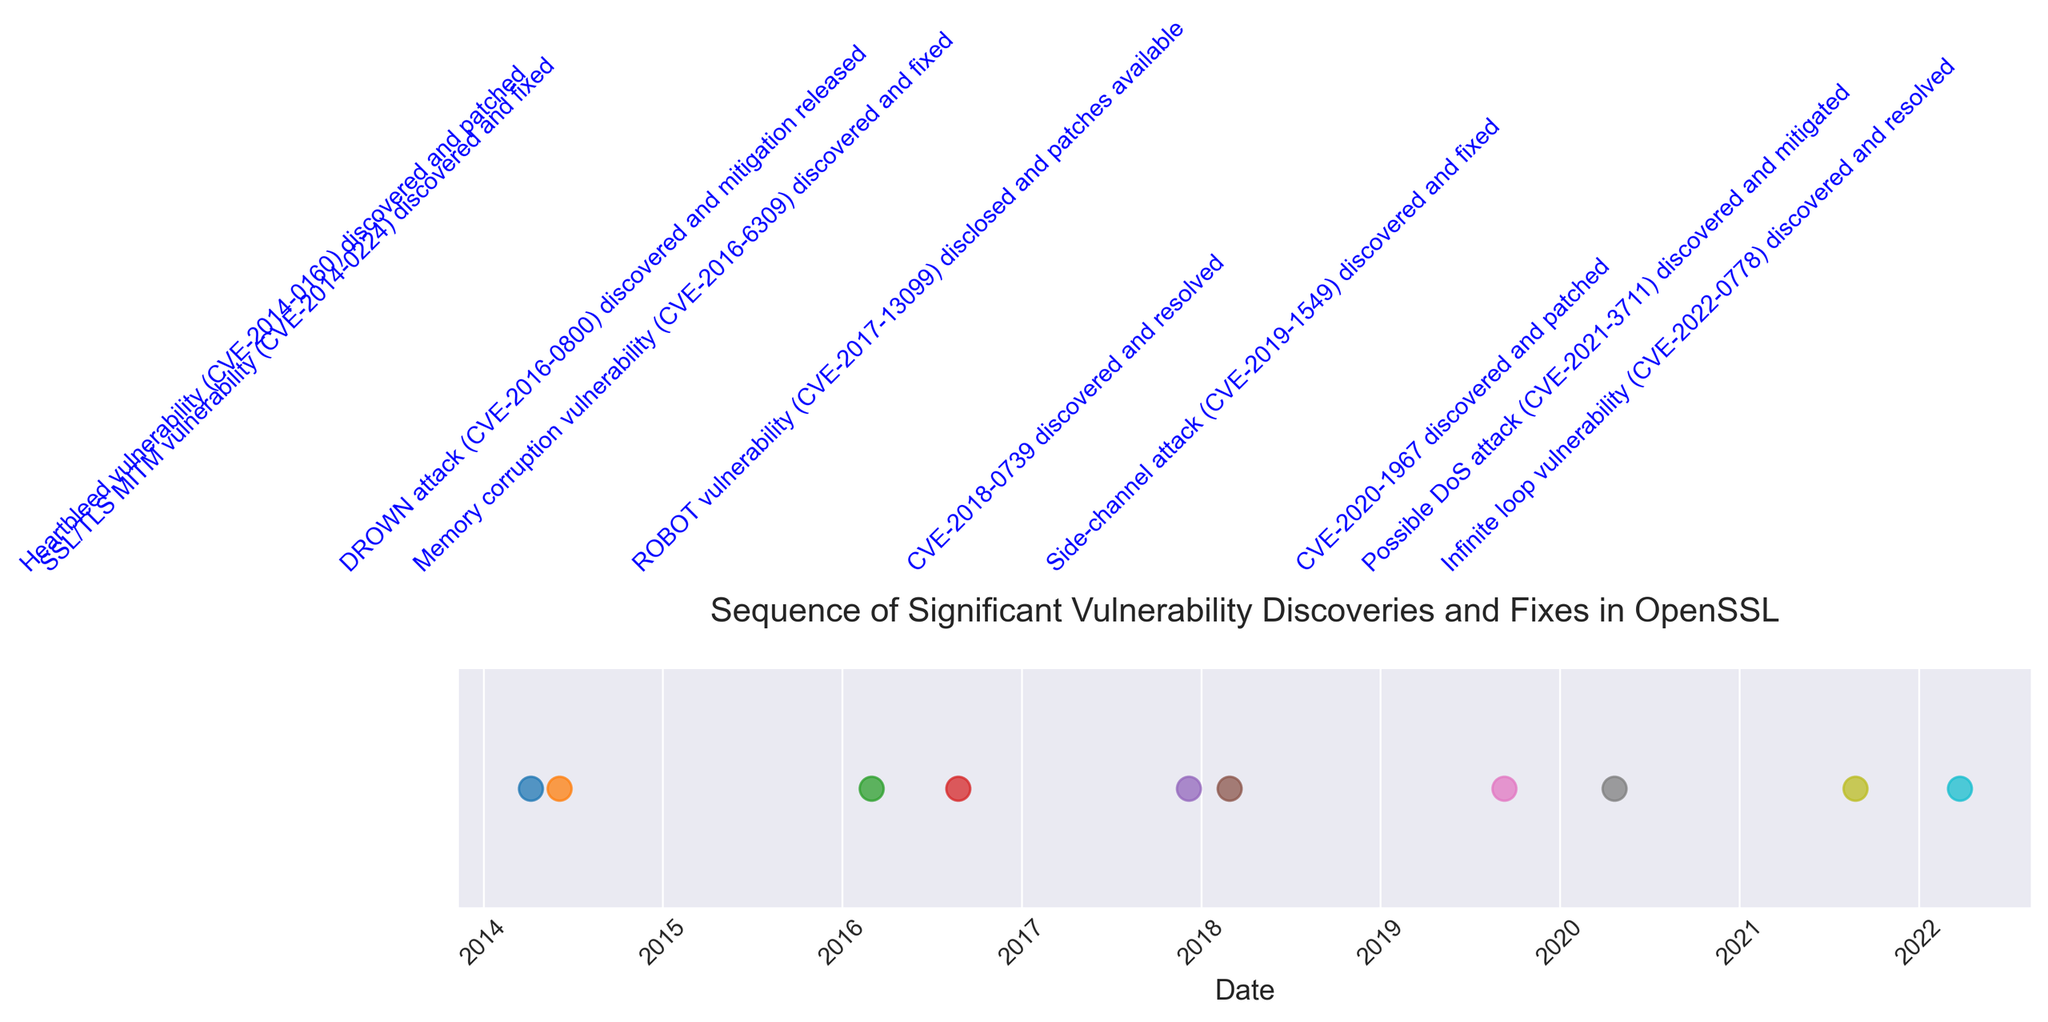When was the Heartbleed vulnerability discovered and patched? The event text directly states the Heartbleed vulnerability (CVE-2014-0160) was discovered and patched on 2014-04-07.
Answer: 2014-04-07 How many vulnerabilities were discovered between 2014 and 2016? Based on the dates provided in the figure, five vulnerabilities were discovered and fixed between 2014-04-07 and 2016-08-24.
Answer: 5 Which year had the highest number of significant vulnerabilities discovered and fixed? By counting the number of events per year, 2016 had the highest number of events with two significant vulnerabilities discovered and fixed.
Answer: 2016 Which event occurred last in the timeline? The last event on the timeline is the Infinite loop vulnerability (CVE-2022-0778) discovered and resolved, which occurred on 2022-03-25.
Answer: Infinite loop vulnerability (CVE-2022-0778) Comparing the Heartbleed vulnerability and the Infinite loop vulnerability, which one happened first? The Heartbleed vulnerability happened on 2014-04-07, whereas the Infinite loop vulnerability happened on 2022-03-25. Therefore, the Heartbleed vulnerability occurred first.
Answer: Heartbleed vulnerability What is the median date for the vulnerability fixes listed in the figure? To find the median date, first arrange all dates in chronological order and find the middle value. The middle date is 2017-12-07 (ROBOT vulnerability).
Answer: 2017-12-07 Were there more vulnerabilities discovered in the first or second half of the displayed timeline (2014-2022)? Dividing the timeline into two halves (2014-2018 and 2019-2022), there are 6 vulnerabilities in the first half and 4 in the second half. Thus, more vulnerabilities were discovered in the first half.
Answer: First half (2014-2018) Which event is associated with the earliest date in the figure? The Heartbleed vulnerability (CVE-2014-0160) is associated with the earliest date, 2014-04-07, in the timeline.
Answer: Heartbleed vulnerability (CVE-2014-0160) How long after the discovery of the DROWN attack was the CVE-2016-6309 vulnerability discovered? The DROWN attack was discovered on 2016-03-01, and the CVE-2016-6309 was discovered on 2016-08-24. The time difference is 5 months and 23 days.
Answer: 5 months, 23 days 